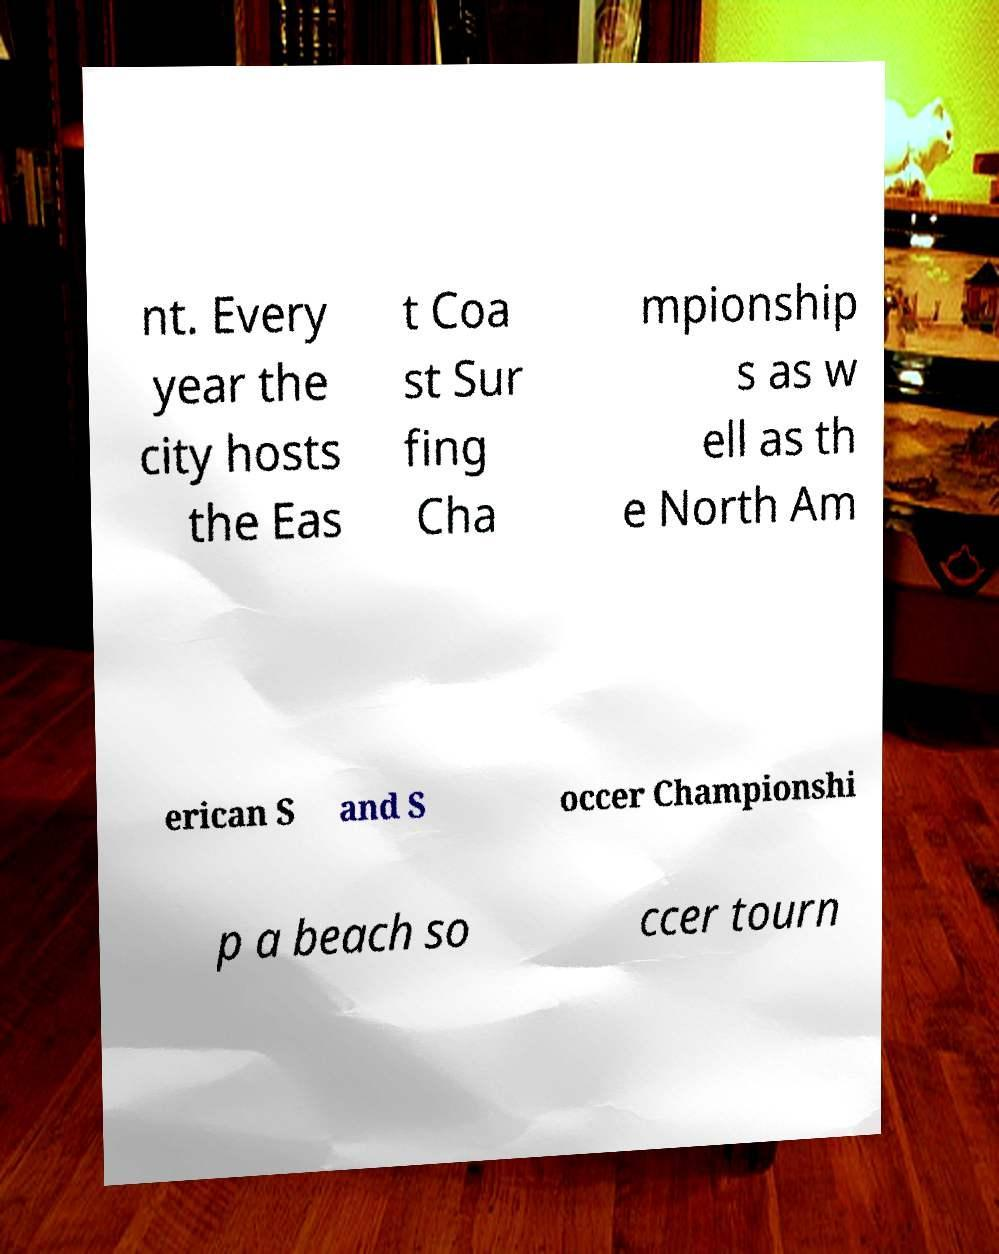There's text embedded in this image that I need extracted. Can you transcribe it verbatim? nt. Every year the city hosts the Eas t Coa st Sur fing Cha mpionship s as w ell as th e North Am erican S and S occer Championshi p a beach so ccer tourn 